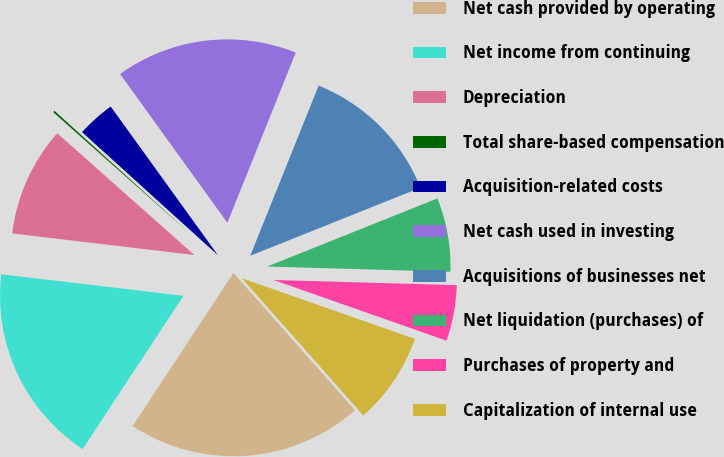Convert chart to OTSL. <chart><loc_0><loc_0><loc_500><loc_500><pie_chart><fcel>Net cash provided by operating<fcel>Net income from continuing<fcel>Depreciation<fcel>Total share-based compensation<fcel>Acquisition-related costs<fcel>Net cash used in investing<fcel>Acquisitions of businesses net<fcel>Net liquidation (purchases) of<fcel>Purchases of property and<fcel>Capitalization of internal use<nl><fcel>20.79%<fcel>17.62%<fcel>9.68%<fcel>0.16%<fcel>3.34%<fcel>16.03%<fcel>12.86%<fcel>6.51%<fcel>4.92%<fcel>8.1%<nl></chart> 